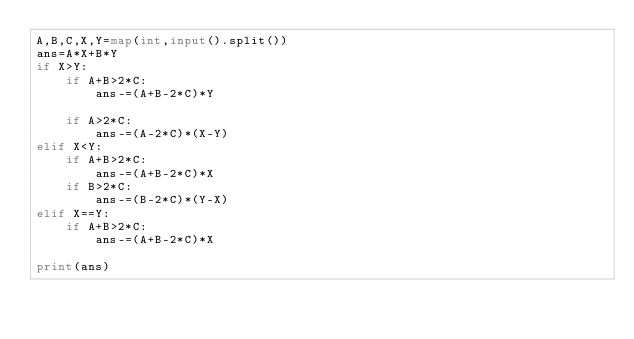<code> <loc_0><loc_0><loc_500><loc_500><_Python_>A,B,C,X,Y=map(int,input().split())
ans=A*X+B*Y
if X>Y:
    if A+B>2*C:
        ans-=(A+B-2*C)*Y

    if A>2*C:
        ans-=(A-2*C)*(X-Y)
elif X<Y:
    if A+B>2*C:
        ans-=(A+B-2*C)*X
    if B>2*C:
        ans-=(B-2*C)*(Y-X)
elif X==Y:
    if A+B>2*C:
        ans-=(A+B-2*C)*X

print(ans)</code> 